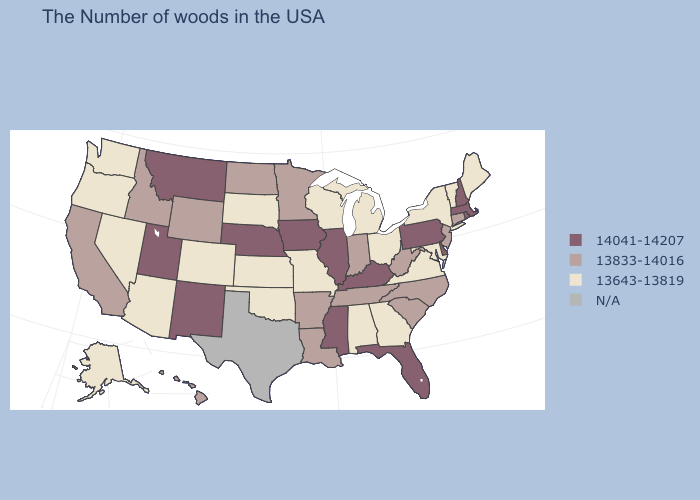What is the value of Nevada?
Quick response, please. 13643-13819. Does Florida have the highest value in the USA?
Quick response, please. Yes. What is the highest value in the USA?
Keep it brief. 14041-14207. Does the first symbol in the legend represent the smallest category?
Write a very short answer. No. Name the states that have a value in the range N/A?
Answer briefly. Texas. Among the states that border Michigan , which have the highest value?
Write a very short answer. Indiana. What is the lowest value in the USA?
Be succinct. 13643-13819. Name the states that have a value in the range N/A?
Be succinct. Texas. How many symbols are there in the legend?
Give a very brief answer. 4. What is the lowest value in the Northeast?
Quick response, please. 13643-13819. Among the states that border Delaware , which have the highest value?
Keep it brief. Pennsylvania. What is the highest value in the Northeast ?
Answer briefly. 14041-14207. What is the value of Colorado?
Concise answer only. 13643-13819. Name the states that have a value in the range 14041-14207?
Concise answer only. Massachusetts, Rhode Island, New Hampshire, Delaware, Pennsylvania, Florida, Kentucky, Illinois, Mississippi, Iowa, Nebraska, New Mexico, Utah, Montana. 